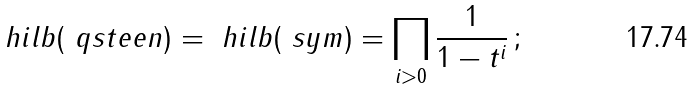Convert formula to latex. <formula><loc_0><loc_0><loc_500><loc_500>\ h i l b ( \ q s t e e n ) = \ h i l b ( \ s y m ) = \prod _ { i > 0 } \frac { 1 } { 1 - t ^ { i } } \, ;</formula> 